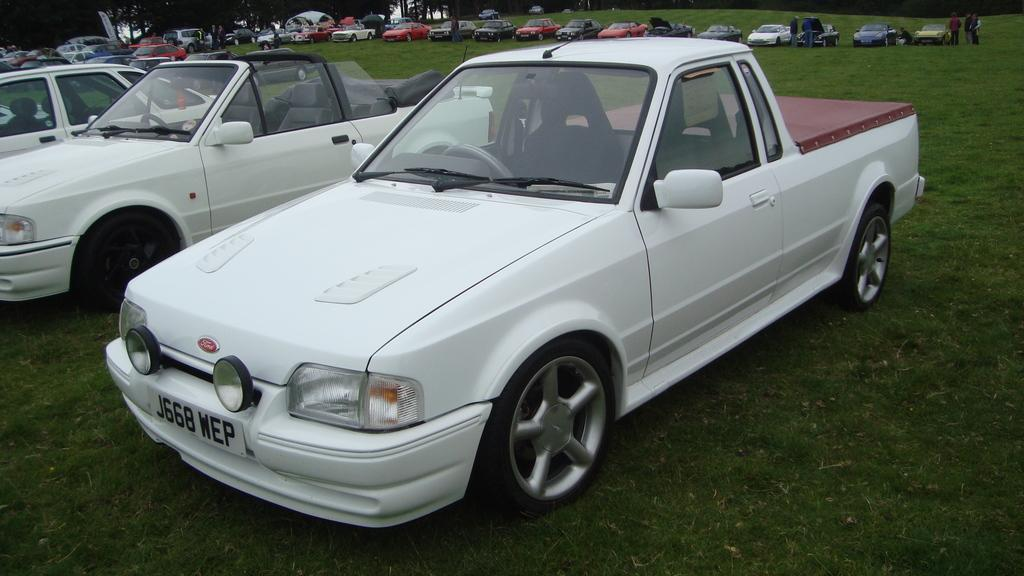What type of vehicles are present in the image? There are cars in the image. How are the cars positioned in the image? The cars are parked on the ground. Are there any people visible in the image? Yes, there are people in the image. What type of natural elements can be seen in the image? There are trees in the image. What type of organization is being held under the net in the image? There is no net or organization present in the image. 